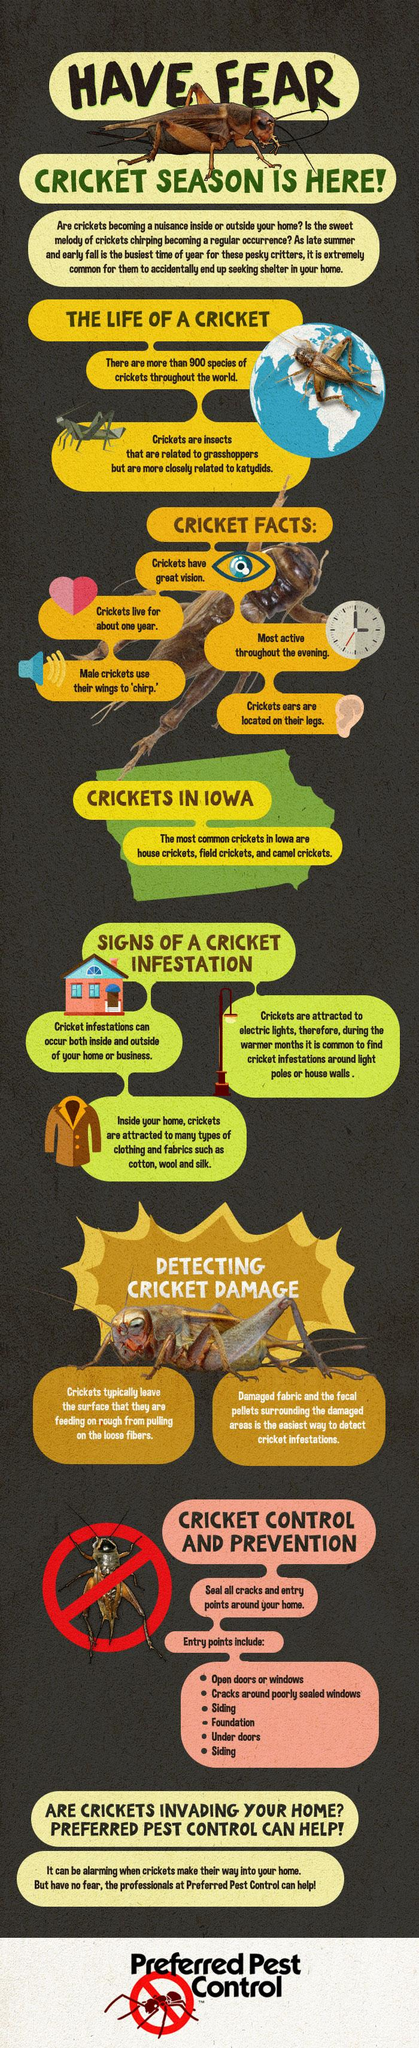Draw attention to some important aspects in this diagram. The fourth entry point mentioned in the infographic is "Foundation. There are three types of crickets found in the state of Iowa. Crickets are drawn to three types of fabric mentioned in this infographic. The lifespan of cricket is approximately one year, a limited period of time compared to other living creatures. In cricket, the gender that uses their wings to chirp is the female, while the male does not use their wings in this way. 